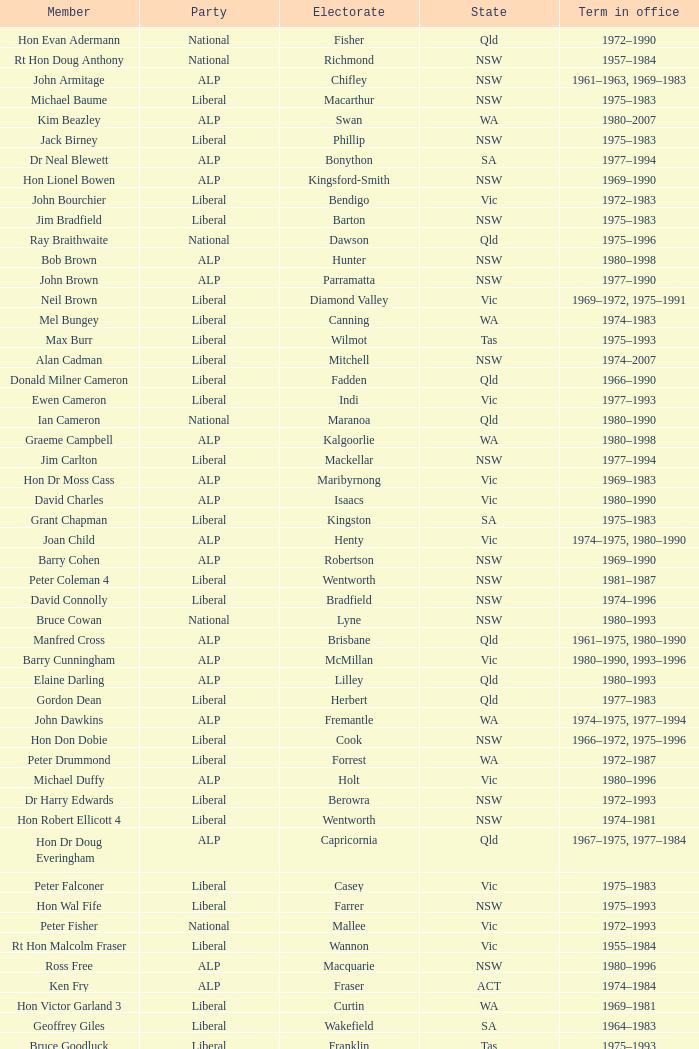What political group does mick young belong to? ALP. 